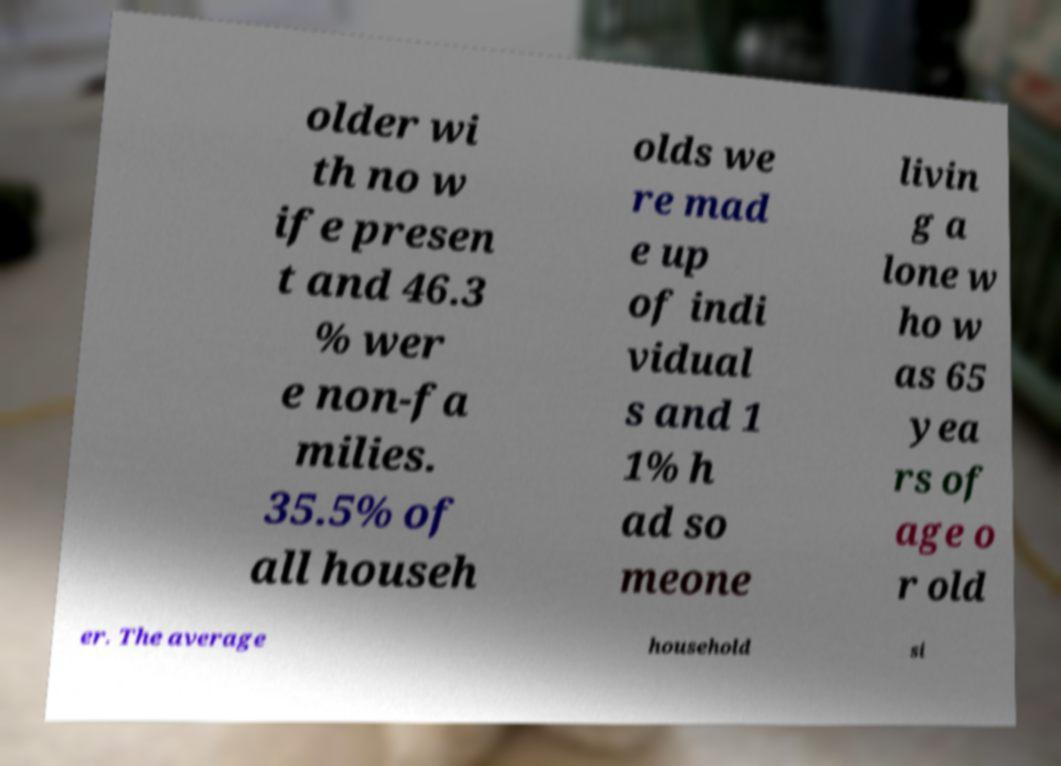For documentation purposes, I need the text within this image transcribed. Could you provide that? older wi th no w ife presen t and 46.3 % wer e non-fa milies. 35.5% of all househ olds we re mad e up of indi vidual s and 1 1% h ad so meone livin g a lone w ho w as 65 yea rs of age o r old er. The average household si 